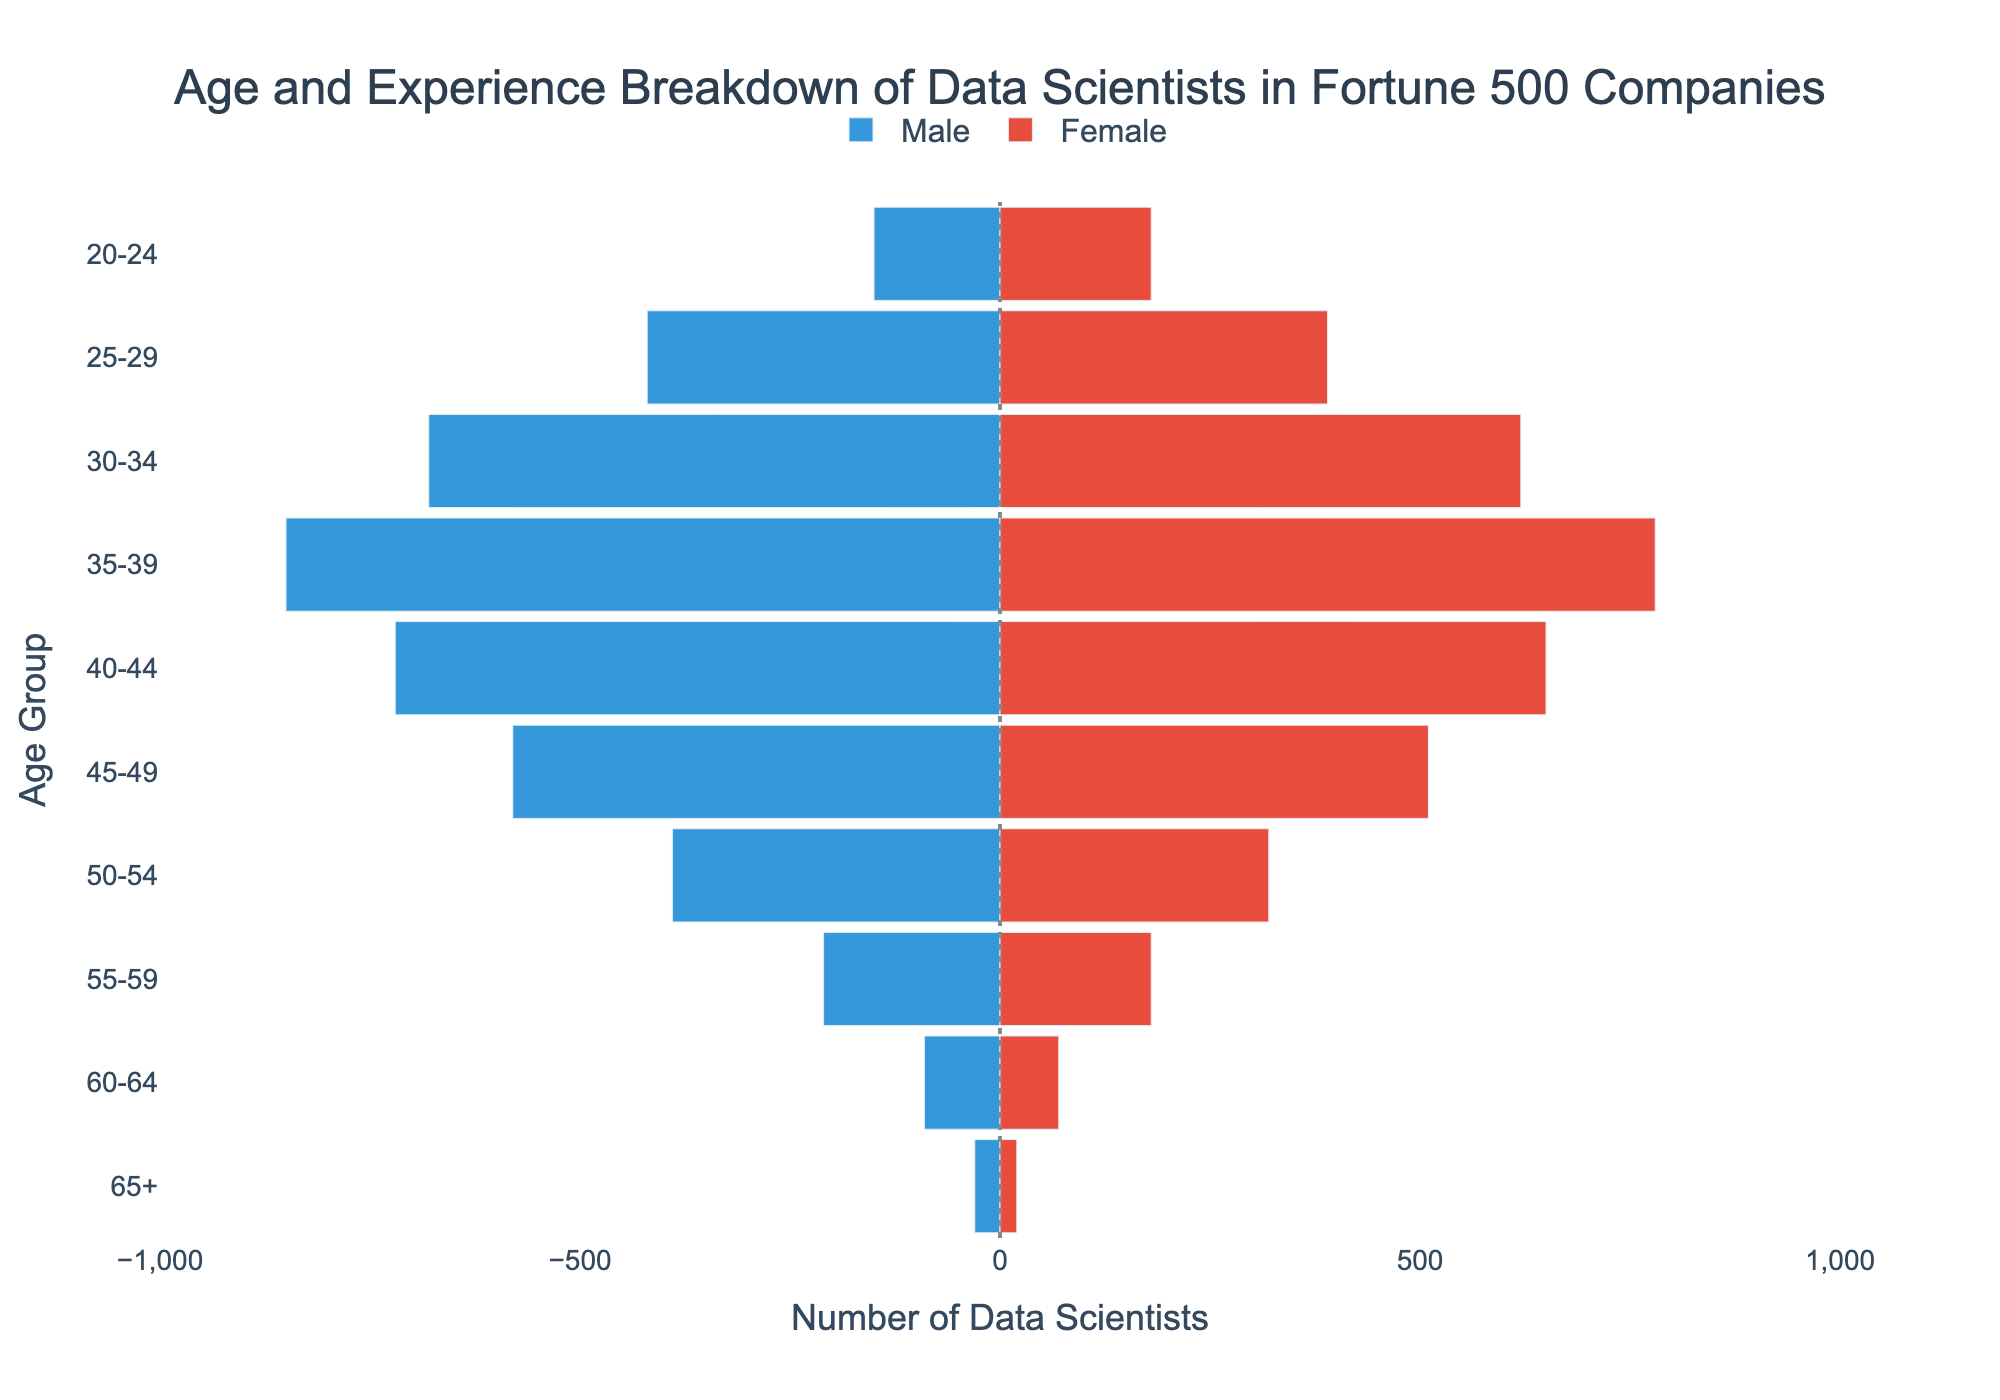What is the title of the figure? The title is prominently displayed at the top center of the figure and is written in a larger font size for emphasis. It reads: "Age and Experience Breakdown of Data Scientists in Fortune 500 Companies".
Answer: Age and Experience Breakdown of Data Scientists in Fortune 500 Companies What are the age groups with the highest number of male and female data scientists, respectively? For males, the highest bar extends to the left, corresponding to the 35-39 age group. For females, the highest bar extends to the right, also corresponding to the 35-39 age group.
Answer: 35-39 for both males and females How many female data scientists are in the 40-44 age group? Locate the bar for females in the 40-44 age group. The value displayed alongside the bar defines the number of female data scientists in that category.
Answer: 650 Compare the number of male and female data scientists in the 50-54 age group. Identify the bars for males and females in the 50-54 age group. The value for males is 390, and for females, it is 320. The male number is higher by 70.
Answer: Males: 390, Females: 320 What is the total number of data scientists in the 60-64 age group? Sum the values for males and females in the 60-64 age group: 90 (male) + 70 (female) = 160.
Answer: 160 Which age group has the smallest number of female data scientists? Find the bar representing females that extend the least. The age group corresponding to this is 65+, with only 20 female data scientists.
Answer: 65+ What is the difference in the number of male data scientists between the 25-29 and 55-59 age groups? Subtract the number of males in the 55-59 age group (210) from those in the 25-29 age group (420). The difference is 210.
Answer: 210 Identify the age group with nearly equal numbers of male and female data scientists. Look for age groups where the lengths of the bars for male and female data scientists are the closest. The 40-44 age group has relatively similar counts, with 720 males and 650 females.
Answer: 40-44 How does the number of data scientists change as the age group increases from 20-24 to 65+? Observe the bars representing male and female data scientists across age groups incrementally. There's a general decline in numbers as age increases, peaking at the 35-39 age group and then gradually decreasing.
Answer: Decreases What is the visual significance of the vertical line at x=0 in the figure? The vertical line at x=0 serves as a reference point to differentiate between male and female data scientists. Bars extending to the left represent males, while those extending to the right represent females. This clear visual demarcation facilitates comparison between the two genders.
Answer: Differentiates between males and females 